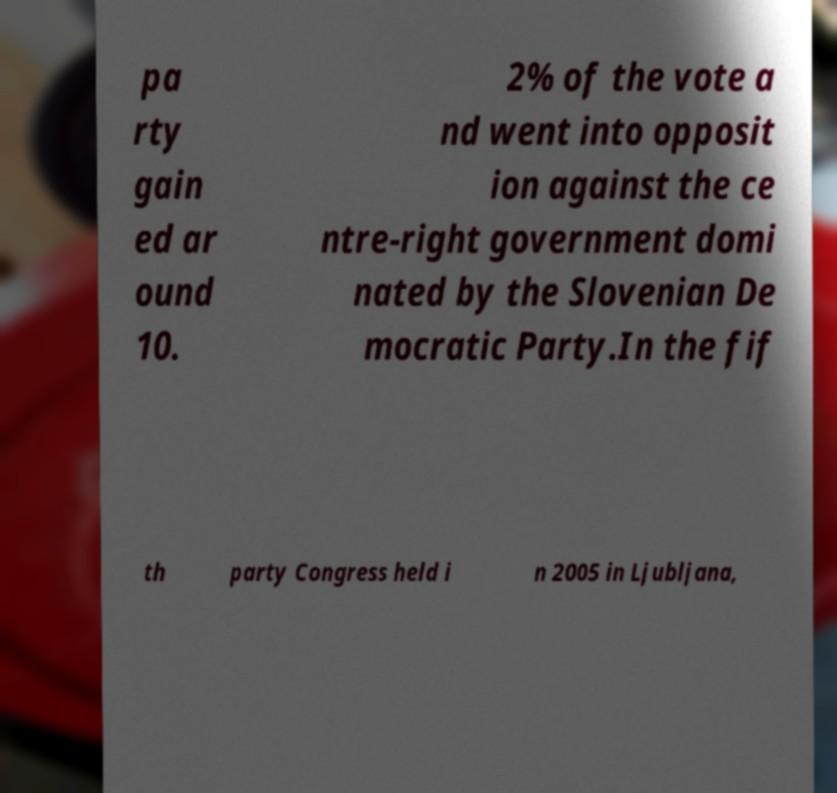Could you assist in decoding the text presented in this image and type it out clearly? pa rty gain ed ar ound 10. 2% of the vote a nd went into opposit ion against the ce ntre-right government domi nated by the Slovenian De mocratic Party.In the fif th party Congress held i n 2005 in Ljubljana, 